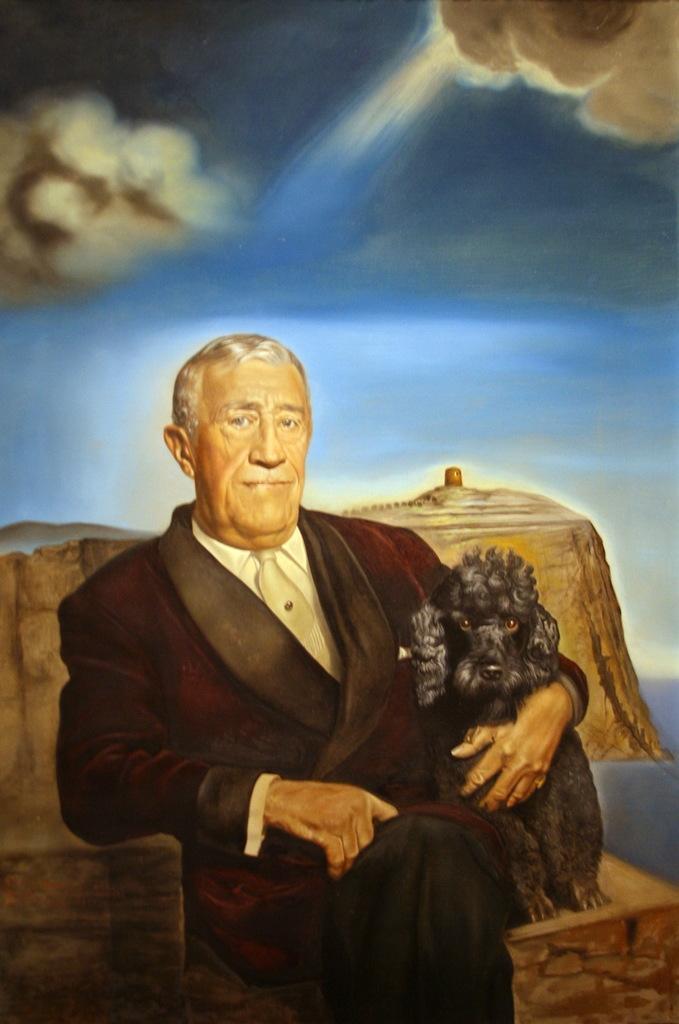In one or two sentences, can you explain what this image depicts? This is the painting image in which there is a man sitting and there is an animal sitting along with the man. In the background there are stones and at the top we can see clouds in the sky. 